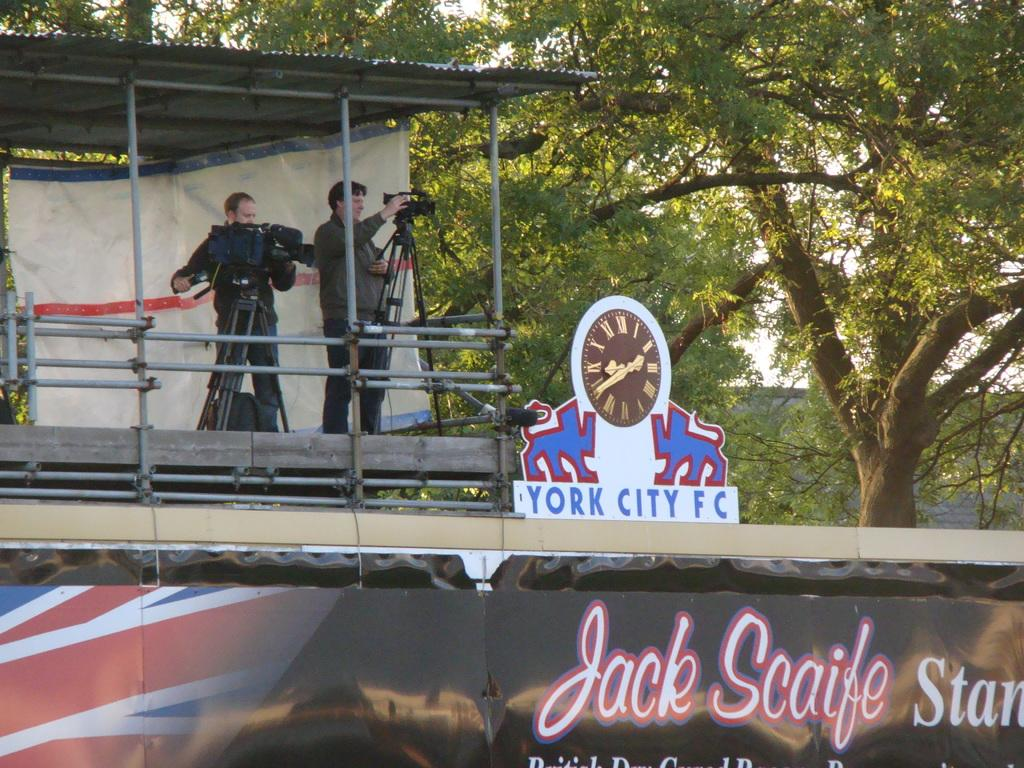<image>
Describe the image concisely. Camera men setting up by a York City FC 